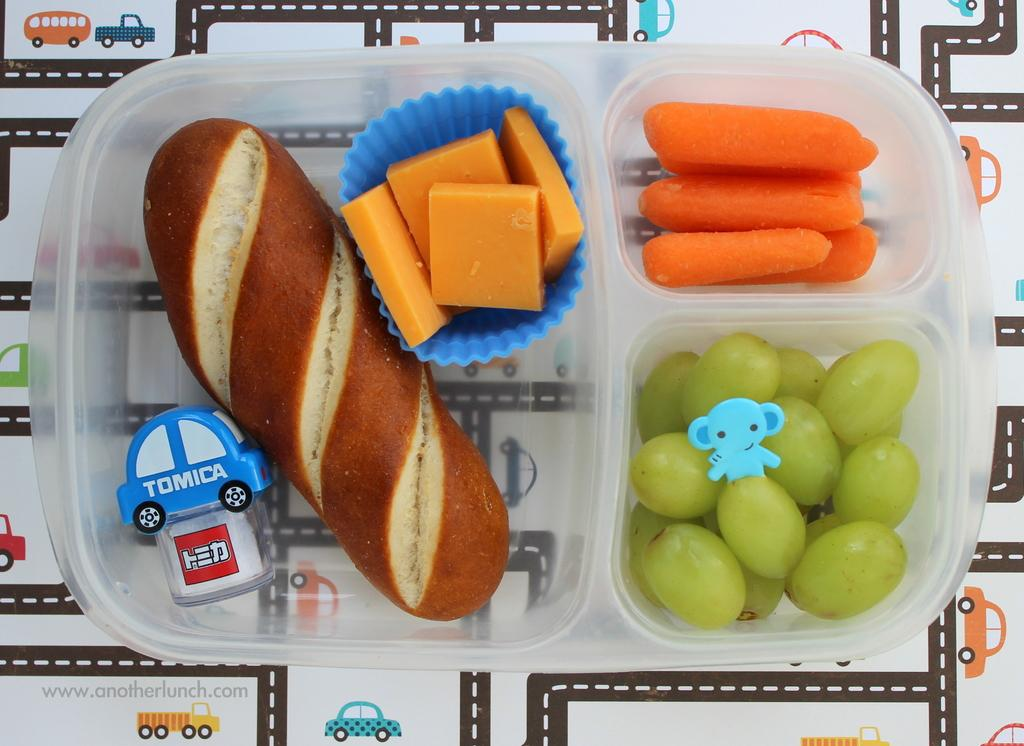What type of container is visible in the image? There is a plastic box in the image. What food items can be seen in the plastic box? Bread, muffins, grapes, and carrots are present in the plastic box. Are there any non-food items in the plastic box? Yes, a toy is present in the plastic box. Can you describe the setting in which the image may have been taken? The image may have been taken in a room. What type of building can be seen in the background of the image? There is no building visible in the image; it only shows the contents of a plastic box. 